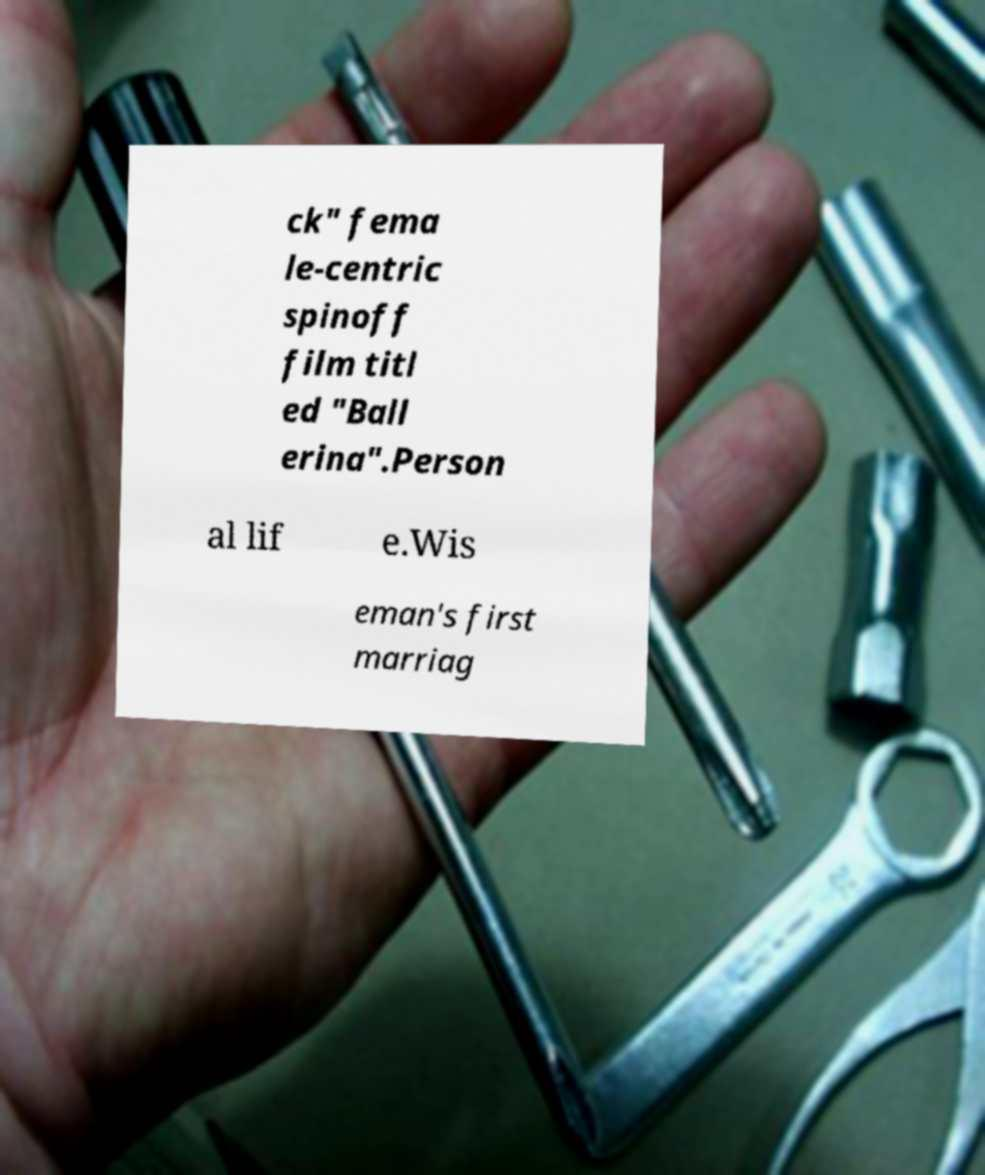What messages or text are displayed in this image? I need them in a readable, typed format. ck" fema le-centric spinoff film titl ed "Ball erina".Person al lif e.Wis eman's first marriag 